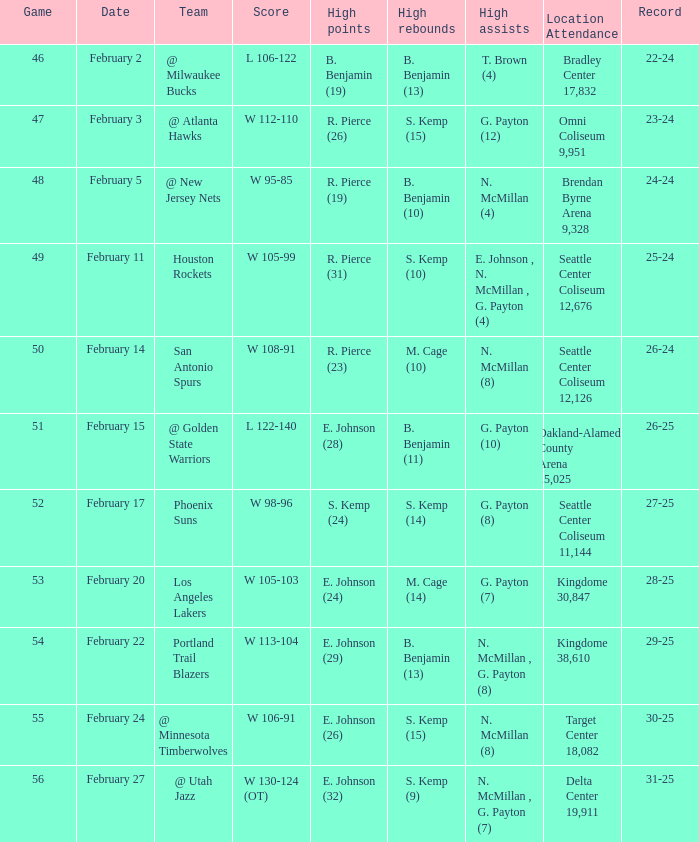Who achieved the peak points when the score was w 112-110? R. Pierce (26). 